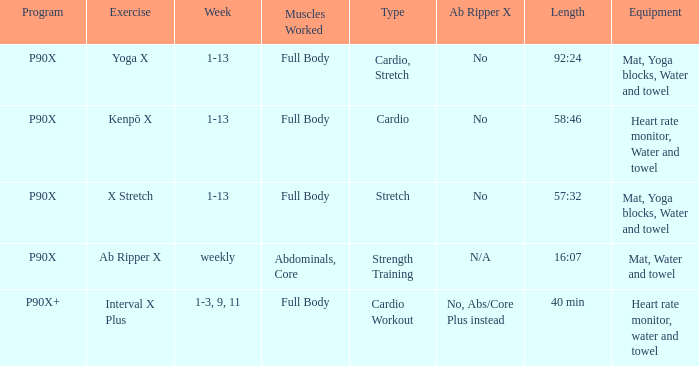In the context of the x stretch exercise, what can be understood as the ab ripper x? No. 